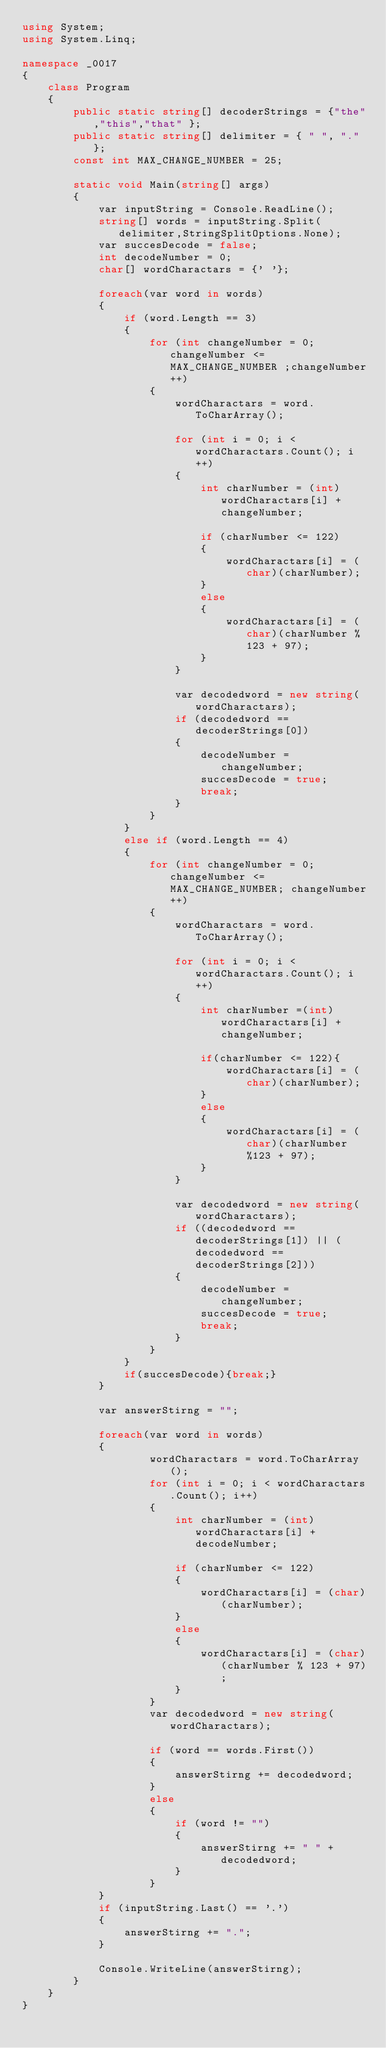<code> <loc_0><loc_0><loc_500><loc_500><_C#_>using System;
using System.Linq;

namespace _0017
{
    class Program
    {
        public static string[] decoderStrings = {"the","this","that" };
        public static string[] delimiter = { " ", "."};
        const int MAX_CHANGE_NUMBER = 25;

        static void Main(string[] args)
        {
            var inputString = Console.ReadLine();
            string[] words = inputString.Split(delimiter,StringSplitOptions.None);
            var succesDecode = false;
            int decodeNumber = 0;
            char[] wordCharactars = {' '};

            foreach(var word in words)
            {
                if (word.Length == 3)
                {
                    for (int changeNumber = 0; changeNumber <= MAX_CHANGE_NUMBER ;changeNumber++)
                    {
                        wordCharactars = word.ToCharArray();

                        for (int i = 0; i < wordCharactars.Count(); i++)
                        {
                            int charNumber = (int)wordCharactars[i] + changeNumber;

                            if (charNumber <= 122)
                            {
                                wordCharactars[i] = (char)(charNumber);
                            }
                            else
                            {
                                wordCharactars[i] = (char)(charNumber % 123 + 97);
                            }
                        }

                        var decodedword = new string(wordCharactars);
                        if (decodedword == decoderStrings[0])
                        {
                            decodeNumber = changeNumber;
                            succesDecode = true;
                            break;
                        }
                    }   
                }
                else if (word.Length == 4)
                {
                    for (int changeNumber = 0; changeNumber <= MAX_CHANGE_NUMBER; changeNumber++)
                    {
                        wordCharactars = word.ToCharArray();

                        for (int i = 0; i < wordCharactars.Count(); i++)
                        {
                            int charNumber =(int)wordCharactars[i] + changeNumber;

                            if(charNumber <= 122){
                                wordCharactars[i] = (char)(charNumber);
                            }
                            else
                            {
                                wordCharactars[i] = (char)(charNumber%123 + 97);
                            }
                        }

                        var decodedword = new string(wordCharactars);
                        if ((decodedword == decoderStrings[1]) || (decodedword == decoderStrings[2]))
                        {
                            decodeNumber = changeNumber;
                            succesDecode = true;
                            break;
                        }
                    }   
                }
                if(succesDecode){break;}
            }

            var answerStirng = "";

            foreach(var word in words)
            {
                    wordCharactars = word.ToCharArray();
                    for (int i = 0; i < wordCharactars.Count(); i++)
                    {
                        int charNumber = (int)wordCharactars[i] + decodeNumber;

                        if (charNumber <= 122)
                        {
                            wordCharactars[i] = (char)(charNumber);
                        }
                        else
                        {
                            wordCharactars[i] = (char)(charNumber % 123 + 97);
                        }
                    }
                    var decodedword = new string(wordCharactars);

                    if (word == words.First())
                    {
                        answerStirng += decodedword;
                    }
                    else 
                    {
                        if (word != "")
                        {
                            answerStirng += " " + decodedword;
                        }
                    }
            }
            if (inputString.Last() == '.')
            {
                answerStirng += ".";
            }

            Console.WriteLine(answerStirng);
        }
    }
}</code> 